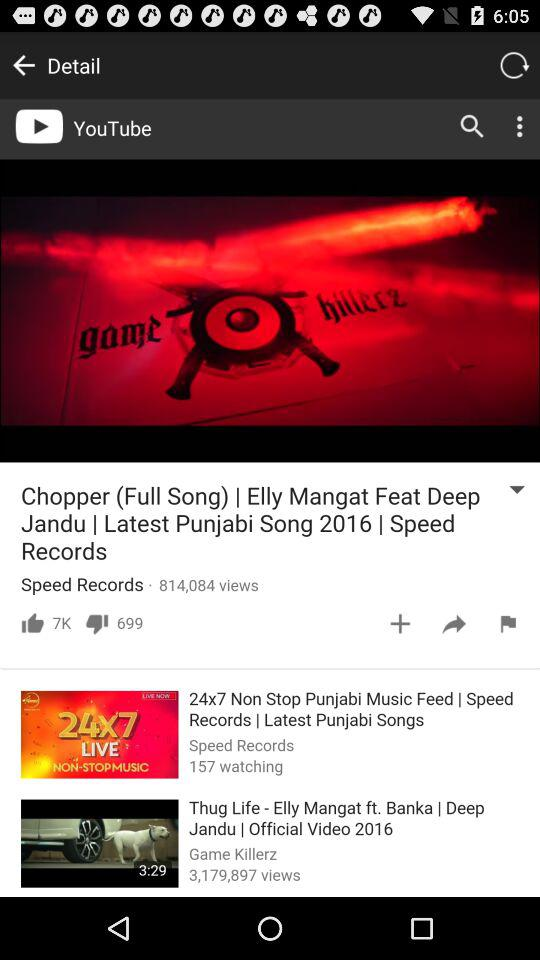How many views are there of the video "Thug Life"? There are 3,179,897 views of the video "Thug Life". 